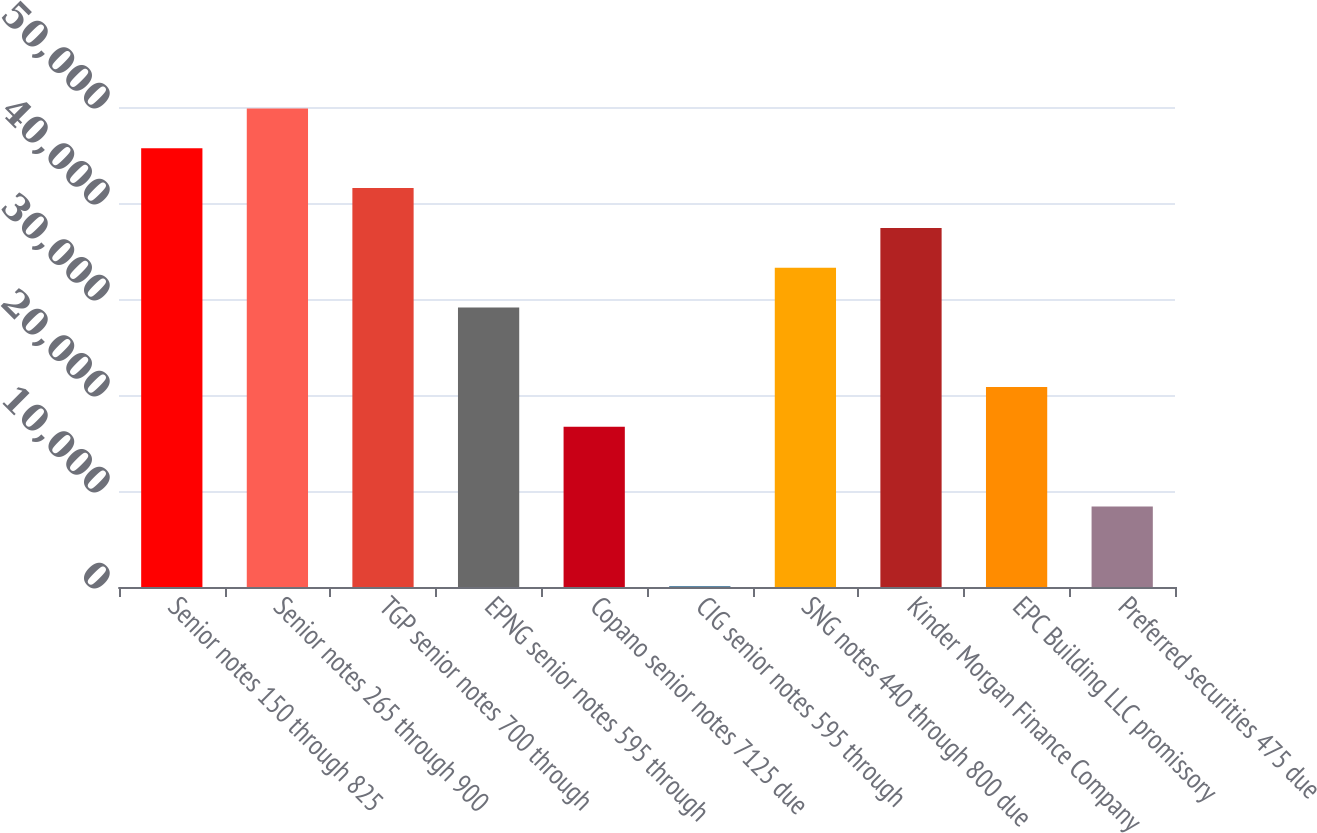Convert chart to OTSL. <chart><loc_0><loc_0><loc_500><loc_500><bar_chart><fcel>Senior notes 150 through 825<fcel>Senior notes 265 through 900<fcel>TGP senior notes 700 through<fcel>EPNG senior notes 595 through<fcel>Copano senior notes 7125 due<fcel>CIG senior notes 595 through<fcel>SNG notes 440 through 800 due<fcel>Kinder Morgan Finance Company<fcel>EPC Building LLC promissory<fcel>Preferred securities 475 due<nl><fcel>45698.3<fcel>49843.6<fcel>41553<fcel>29117.1<fcel>16681.2<fcel>100<fcel>33262.4<fcel>37407.7<fcel>20826.5<fcel>8390.6<nl></chart> 